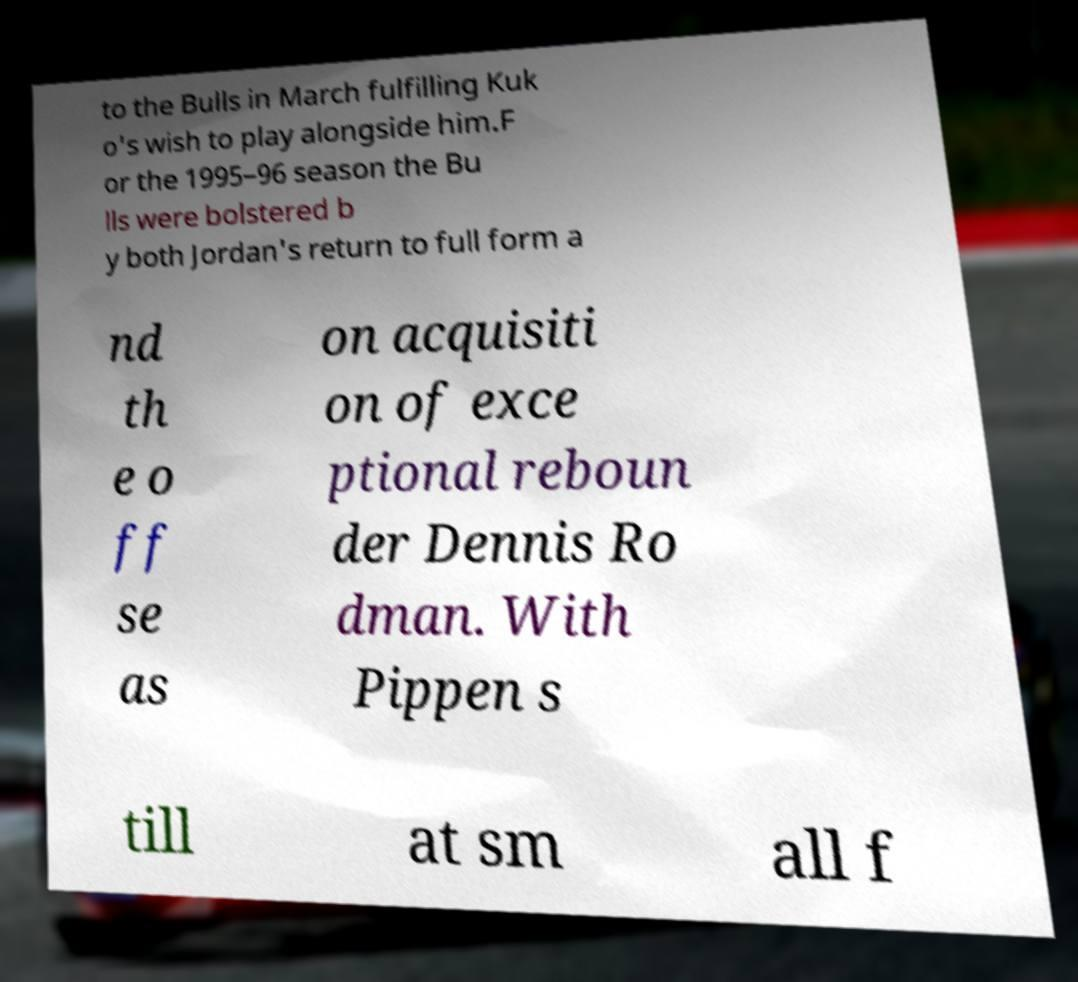Please read and relay the text visible in this image. What does it say? to the Bulls in March fulfilling Kuk o's wish to play alongside him.F or the 1995–96 season the Bu lls were bolstered b y both Jordan's return to full form a nd th e o ff se as on acquisiti on of exce ptional reboun der Dennis Ro dman. With Pippen s till at sm all f 